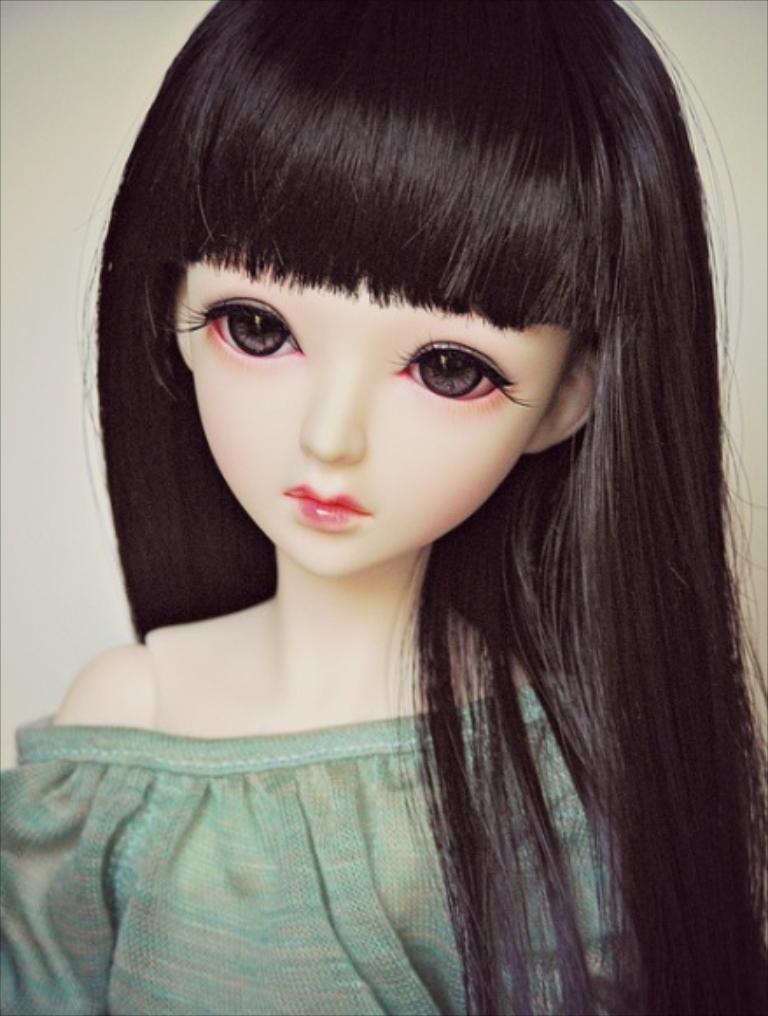In one or two sentences, can you explain what this image depicts? In this image we can see the doll with white background. 